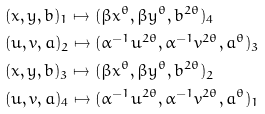<formula> <loc_0><loc_0><loc_500><loc_500>& ( x , y , b ) _ { 1 } \mapsto ( \beta x ^ { \theta } , \beta y ^ { \theta } , b ^ { 2 \theta } ) _ { 4 } \\ & ( u , v , a ) _ { 2 } \mapsto ( \alpha ^ { - 1 } u ^ { 2 \theta } , \alpha ^ { - 1 } v ^ { 2 \theta } , a ^ { \theta } ) _ { 3 } \\ & ( x , y , b ) _ { 3 } \mapsto ( \beta x ^ { \theta } , \beta y ^ { \theta } , b ^ { 2 \theta } ) _ { 2 } \\ & ( u , v , a ) _ { 4 } \mapsto ( \alpha ^ { - 1 } u ^ { 2 \theta } , \alpha ^ { - 1 } v ^ { 2 \theta } , a ^ { \theta } ) _ { 1 }</formula> 